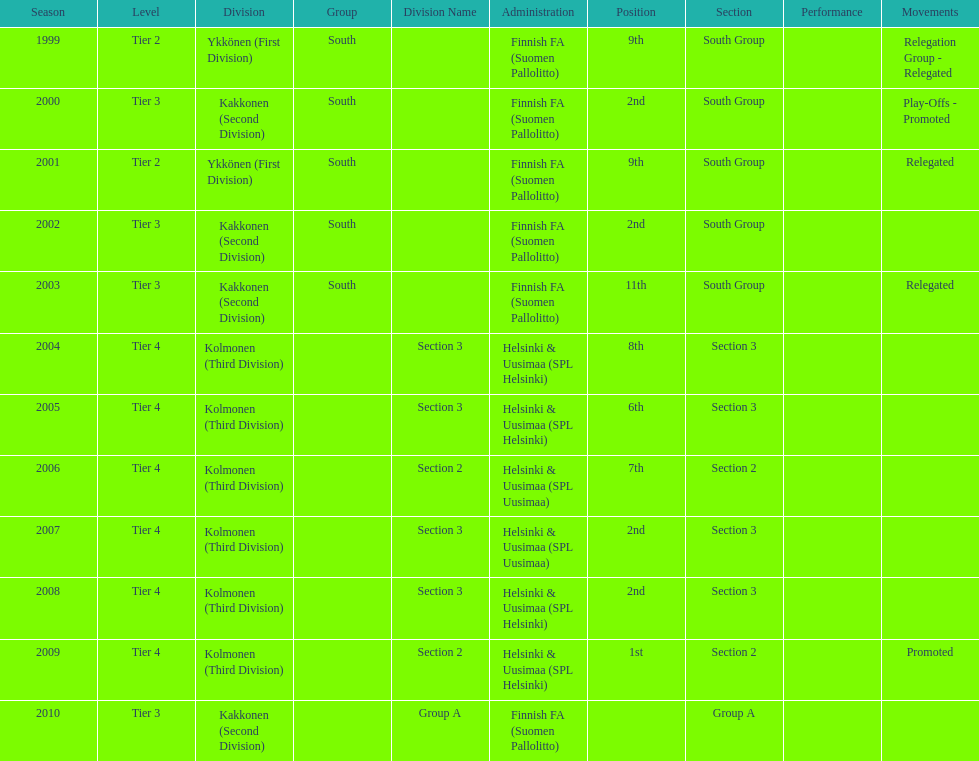Which was the only kolmonen whose movements were promoted? 2009. 